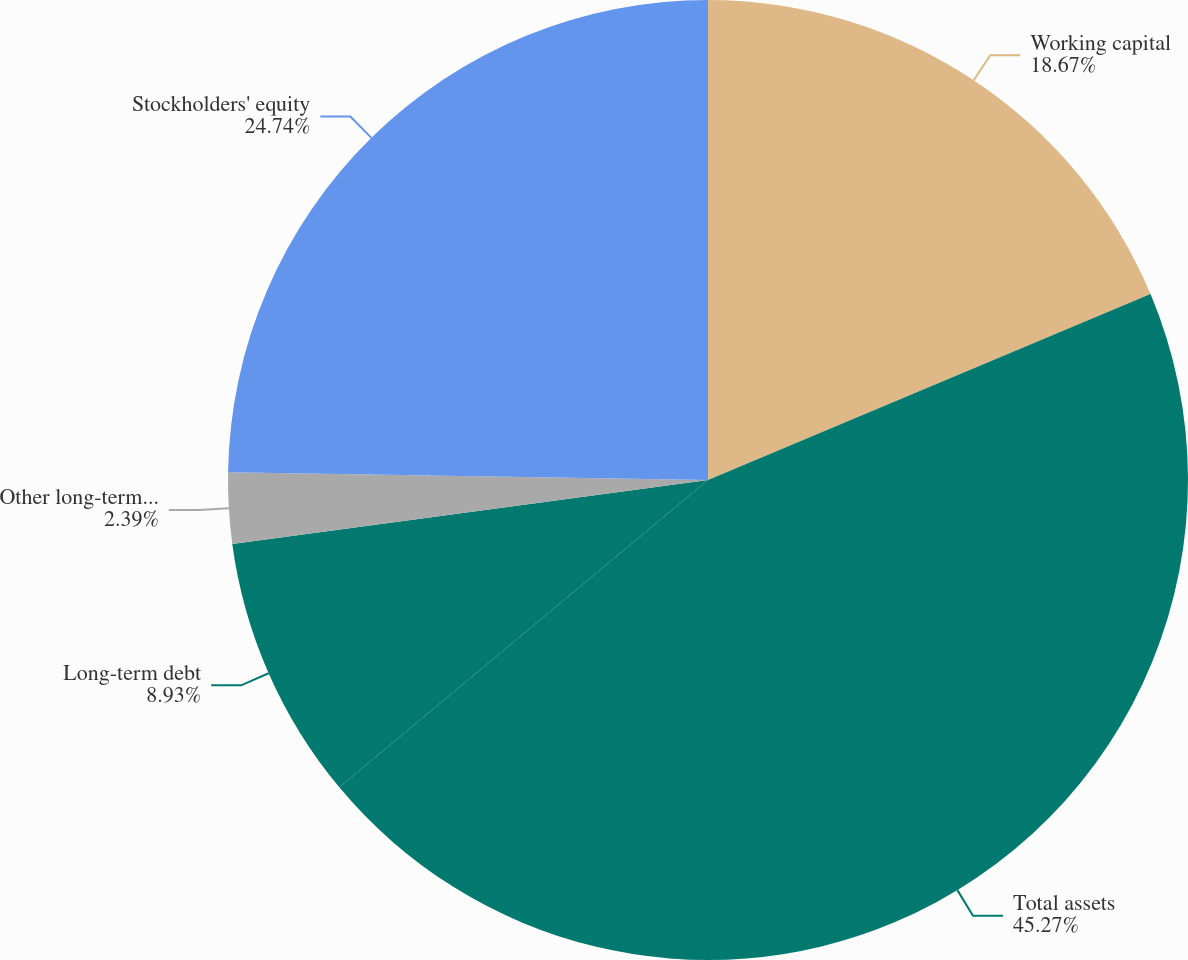<chart> <loc_0><loc_0><loc_500><loc_500><pie_chart><fcel>Working capital<fcel>Total assets<fcel>Long-term debt<fcel>Other long-term liabilities<fcel>Stockholders' equity<nl><fcel>18.67%<fcel>45.27%<fcel>8.93%<fcel>2.39%<fcel>24.74%<nl></chart> 